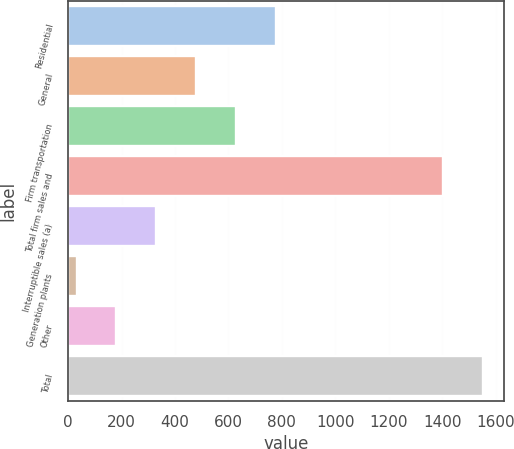Convert chart to OTSL. <chart><loc_0><loc_0><loc_500><loc_500><bar_chart><fcel>Residential<fcel>General<fcel>Firm transportation<fcel>Total firm sales and<fcel>Interruptible sales (a)<fcel>Generation plants<fcel>Other<fcel>Total<nl><fcel>776.5<fcel>478.7<fcel>627.6<fcel>1404<fcel>329.8<fcel>32<fcel>180.9<fcel>1552.9<nl></chart> 